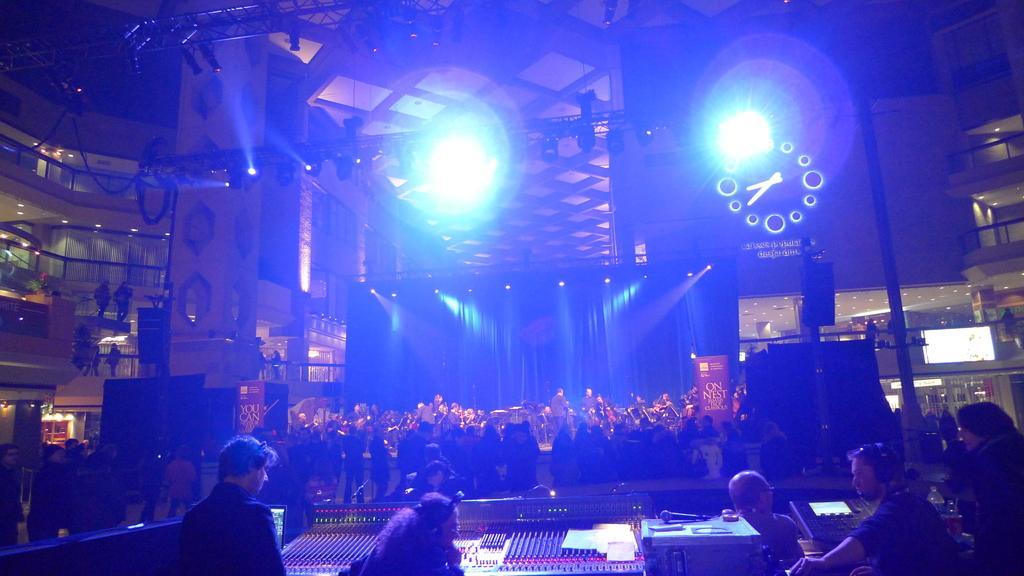How would you summarize this image in a sentence or two? At the bottom of the image few people are standing and sitting. In front of them we can see some electronic devices and microphones. In the middle of the image few people are standing and sitting. Behind them we can see a wall, on the wall we can see some banners and poles. At the top of the image we can see ceiling, lights and poles. 